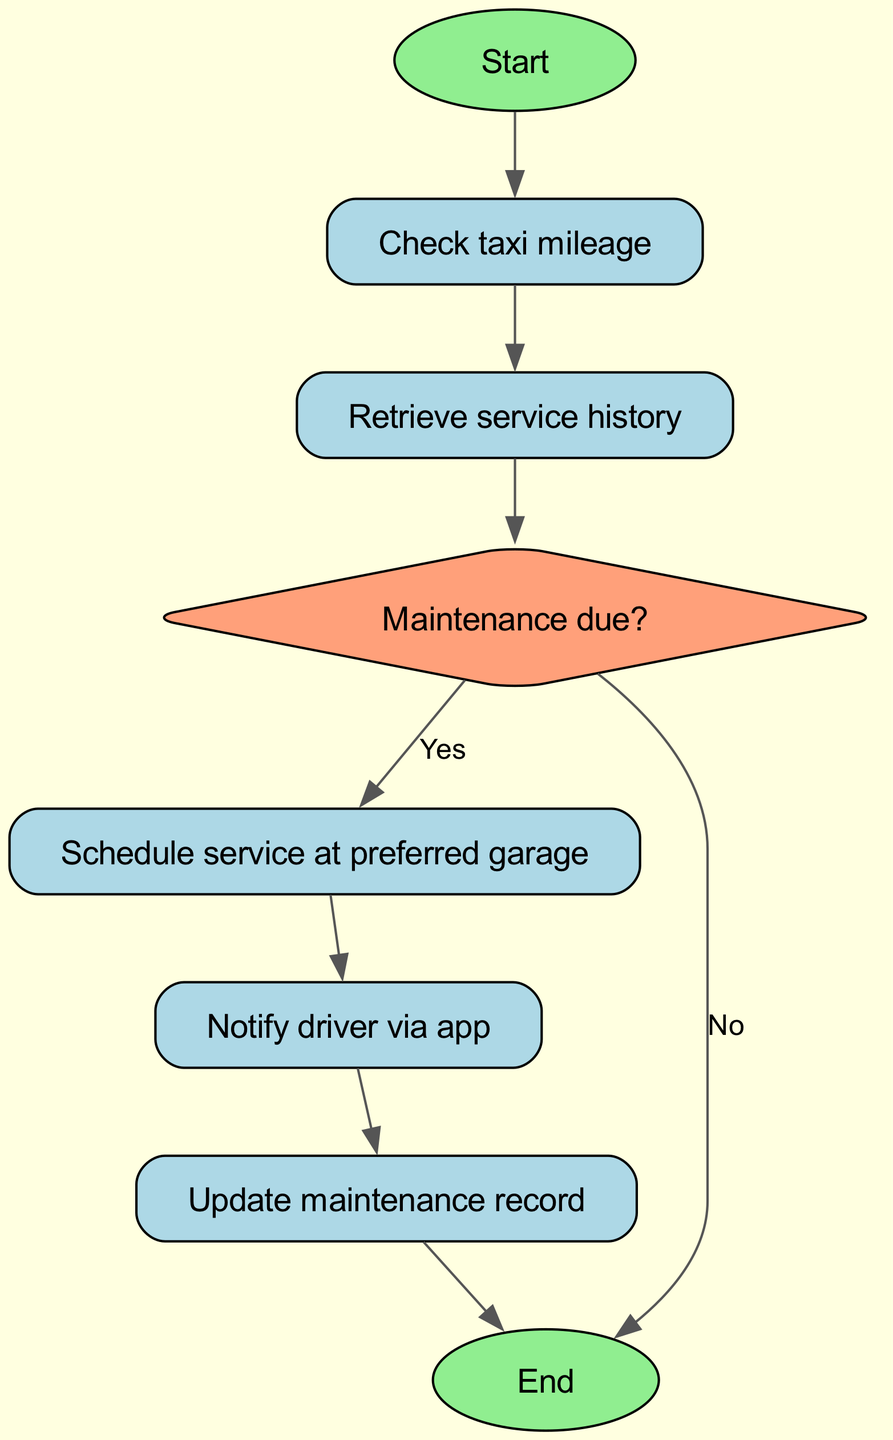What is the first step in the flowchart? The flowchart starts with the "Start" node, indicating the initial step in the process of maintenance scheduling.
Answer: Start How many nodes are there in the diagram? By counting the distinct elements (nodes) in the flowchart, it can be determined that there are a total of eight nodes present.
Answer: Eight What type of node is "maintenance due"? The node labeled "maintenance due" is shaped like a diamond, which indicates a decision point in the flowchart process.
Answer: Diamond What happens if the maintenance is not due? If maintenance is not due, the flowchart directs to the "end" node, indicating that the scheduling process will terminate without scheduling maintenance.
Answer: End Which node directly follows "schedule service"? After the action of "schedule service," the next step in the sequence of operations is to "notify driver," indicating that communication follows scheduling.
Answer: Notify driver What are the two possible outcomes from the "maintenance due" decision node? The decision node "maintenance due" leads to two potential pathways: one is to schedule service (Yes), and the other is to end the process (No), showing the two choices available.
Answer: Yes and No What is the last action in the flowchart? The final operation in the sequence of the flowchart is to "end," marking the conclusion of the automated maintenance scheduling process after updating records.
Answer: End Before notifying the driver, which step must be completed? Before the notification can occur, the step to "schedule service" must first be completed, adhering to the sequence dictated by the flowchart.
Answer: Schedule service 